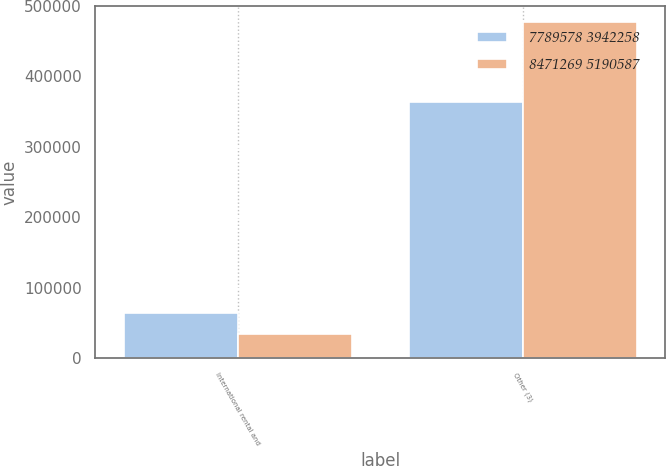<chart> <loc_0><loc_0><loc_500><loc_500><stacked_bar_chart><ecel><fcel>International rental and<fcel>Other (3)<nl><fcel>7789578 3942258<fcel>63956<fcel>363317<nl><fcel>8471269 5190587<fcel>33941<fcel>476618<nl></chart> 